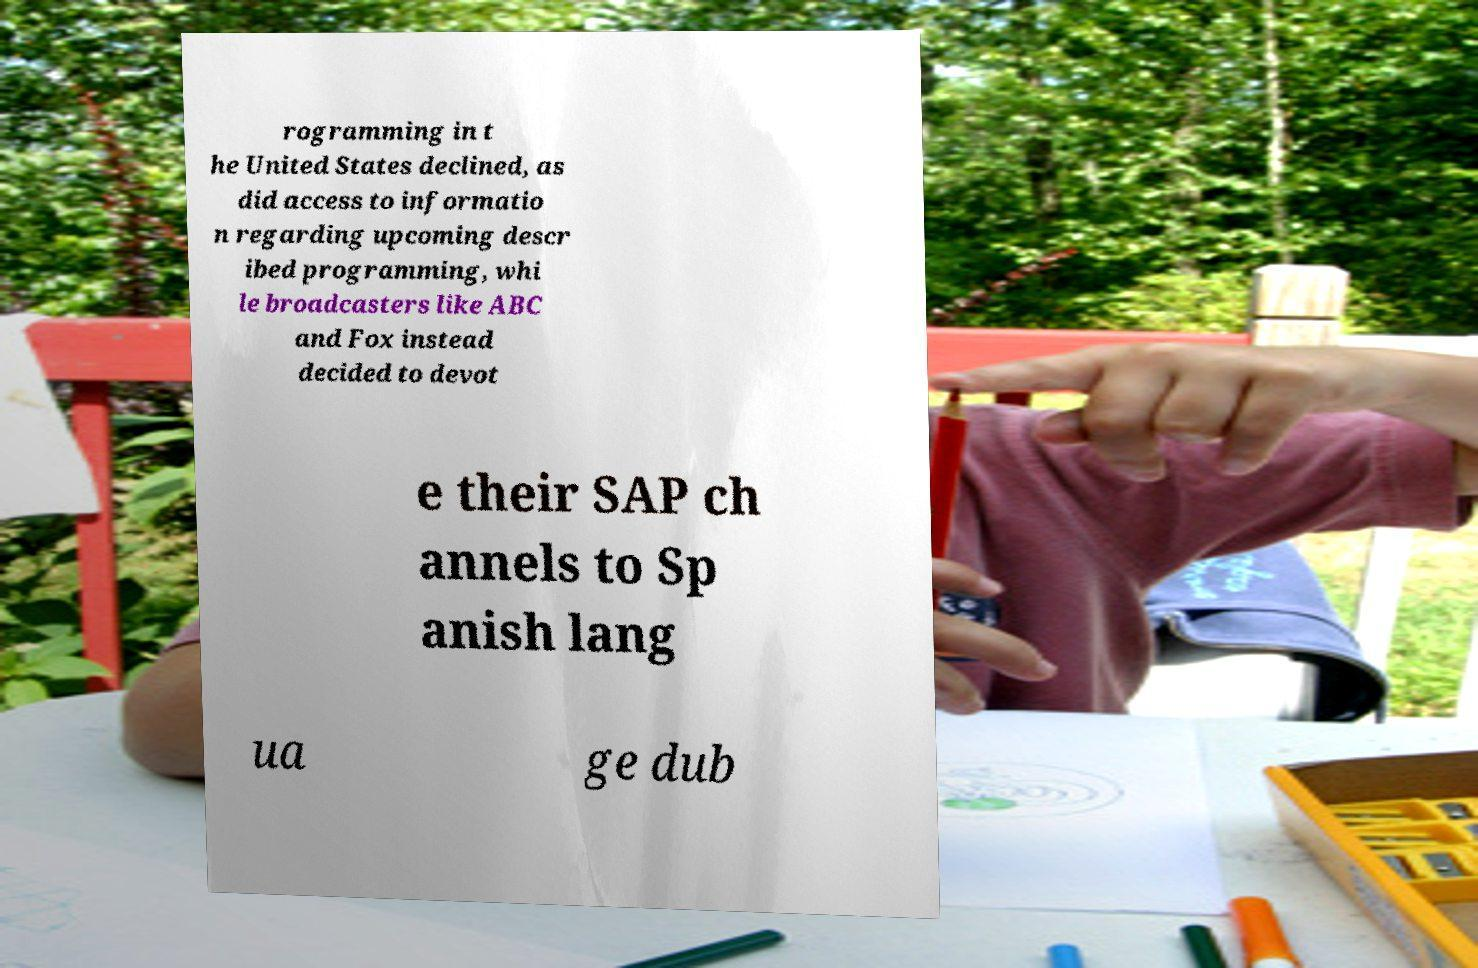What messages or text are displayed in this image? I need them in a readable, typed format. rogramming in t he United States declined, as did access to informatio n regarding upcoming descr ibed programming, whi le broadcasters like ABC and Fox instead decided to devot e their SAP ch annels to Sp anish lang ua ge dub 